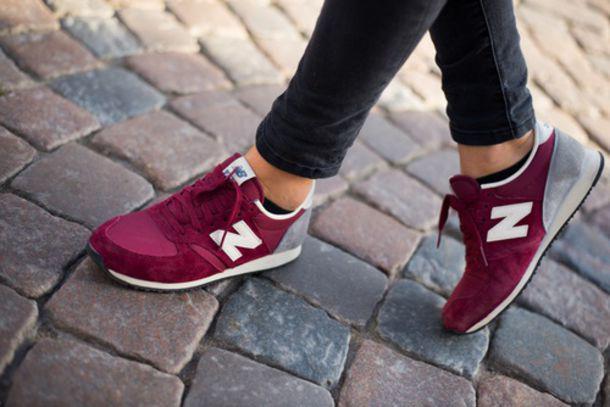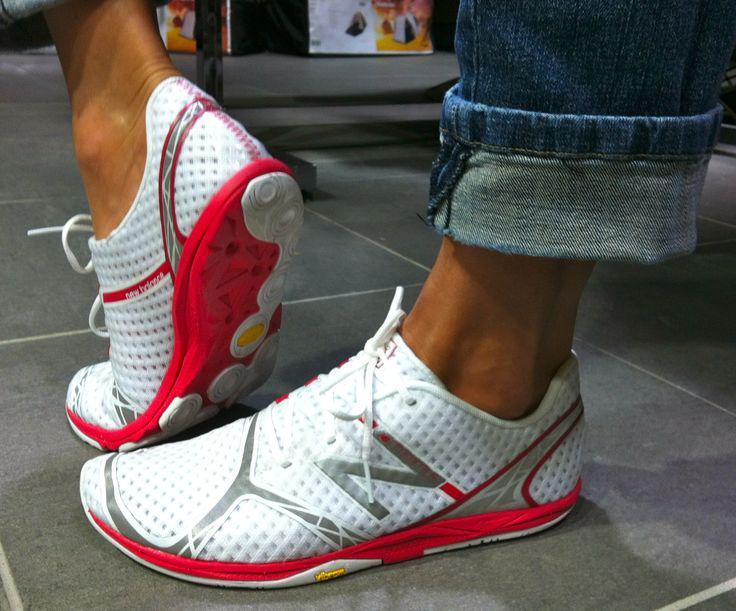The first image is the image on the left, the second image is the image on the right. Examine the images to the left and right. Is the description "In total, two pairs of sneakers are shown." accurate? Answer yes or no. Yes. 